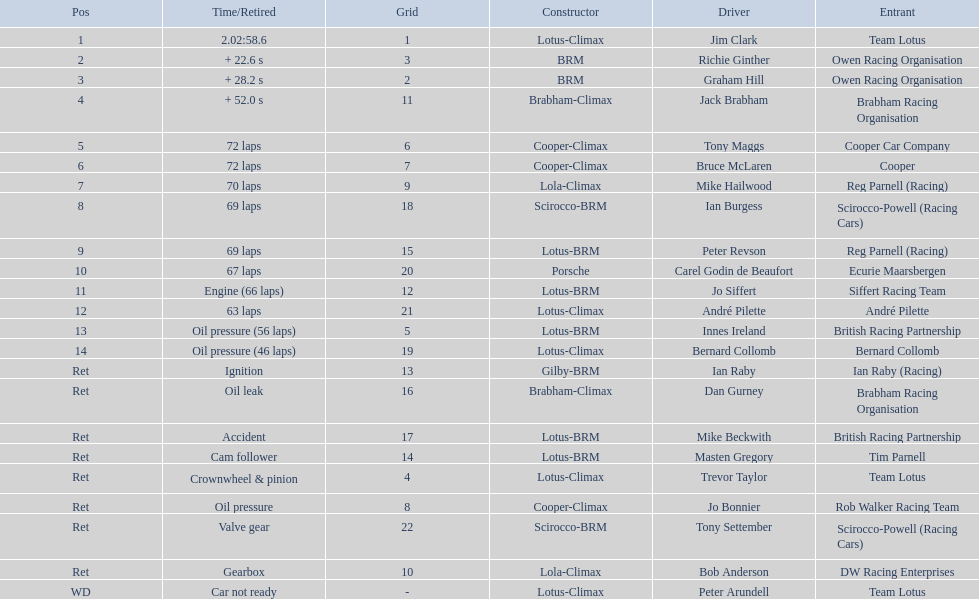Who are all the drivers? Jim Clark, Richie Ginther, Graham Hill, Jack Brabham, Tony Maggs, Bruce McLaren, Mike Hailwood, Ian Burgess, Peter Revson, Carel Godin de Beaufort, Jo Siffert, André Pilette, Innes Ireland, Bernard Collomb, Ian Raby, Dan Gurney, Mike Beckwith, Masten Gregory, Trevor Taylor, Jo Bonnier, Tony Settember, Bob Anderson, Peter Arundell. What were their positions? 1, 2, 3, 4, 5, 6, 7, 8, 9, 10, 11, 12, 13, 14, Ret, Ret, Ret, Ret, Ret, Ret, Ret, Ret, WD. What are all the constructor names? Lotus-Climax, BRM, BRM, Brabham-Climax, Cooper-Climax, Cooper-Climax, Lola-Climax, Scirocco-BRM, Lotus-BRM, Porsche, Lotus-BRM, Lotus-Climax, Lotus-BRM, Lotus-Climax, Gilby-BRM, Brabham-Climax, Lotus-BRM, Lotus-BRM, Lotus-Climax, Cooper-Climax, Scirocco-BRM, Lola-Climax, Lotus-Climax. And which drivers drove a cooper-climax? Tony Maggs, Bruce McLaren. Between those tow, who was positioned higher? Tony Maggs. 